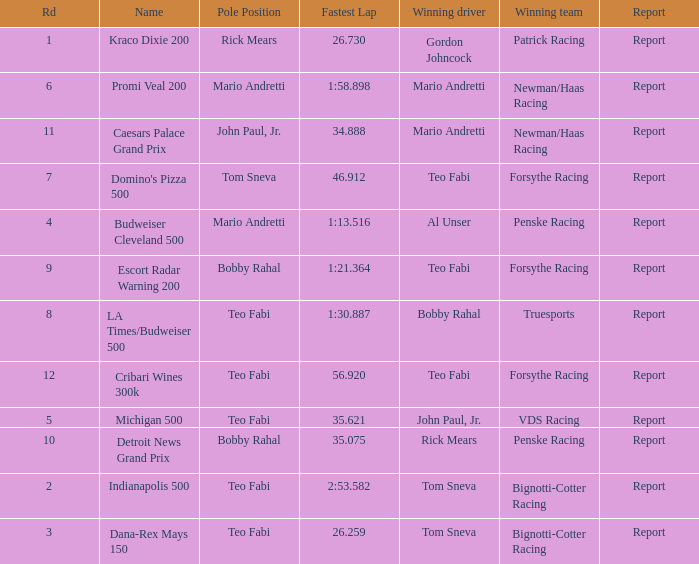What is the highest Rd that Tom Sneva had the pole position in? 7.0. Would you be able to parse every entry in this table? {'header': ['Rd', 'Name', 'Pole Position', 'Fastest Lap', 'Winning driver', 'Winning team', 'Report'], 'rows': [['1', 'Kraco Dixie 200', 'Rick Mears', '26.730', 'Gordon Johncock', 'Patrick Racing', 'Report'], ['6', 'Promi Veal 200', 'Mario Andretti', '1:58.898', 'Mario Andretti', 'Newman/Haas Racing', 'Report'], ['11', 'Caesars Palace Grand Prix', 'John Paul, Jr.', '34.888', 'Mario Andretti', 'Newman/Haas Racing', 'Report'], ['7', "Domino's Pizza 500", 'Tom Sneva', '46.912', 'Teo Fabi', 'Forsythe Racing', 'Report'], ['4', 'Budweiser Cleveland 500', 'Mario Andretti', '1:13.516', 'Al Unser', 'Penske Racing', 'Report'], ['9', 'Escort Radar Warning 200', 'Bobby Rahal', '1:21.364', 'Teo Fabi', 'Forsythe Racing', 'Report'], ['8', 'LA Times/Budweiser 500', 'Teo Fabi', '1:30.887', 'Bobby Rahal', 'Truesports', 'Report'], ['12', 'Cribari Wines 300k', 'Teo Fabi', '56.920', 'Teo Fabi', 'Forsythe Racing', 'Report'], ['5', 'Michigan 500', 'Teo Fabi', '35.621', 'John Paul, Jr.', 'VDS Racing', 'Report'], ['10', 'Detroit News Grand Prix', 'Bobby Rahal', '35.075', 'Rick Mears', 'Penske Racing', 'Report'], ['2', 'Indianapolis 500', 'Teo Fabi', '2:53.582', 'Tom Sneva', 'Bignotti-Cotter Racing', 'Report'], ['3', 'Dana-Rex Mays 150', 'Teo Fabi', '26.259', 'Tom Sneva', 'Bignotti-Cotter Racing', 'Report']]} 